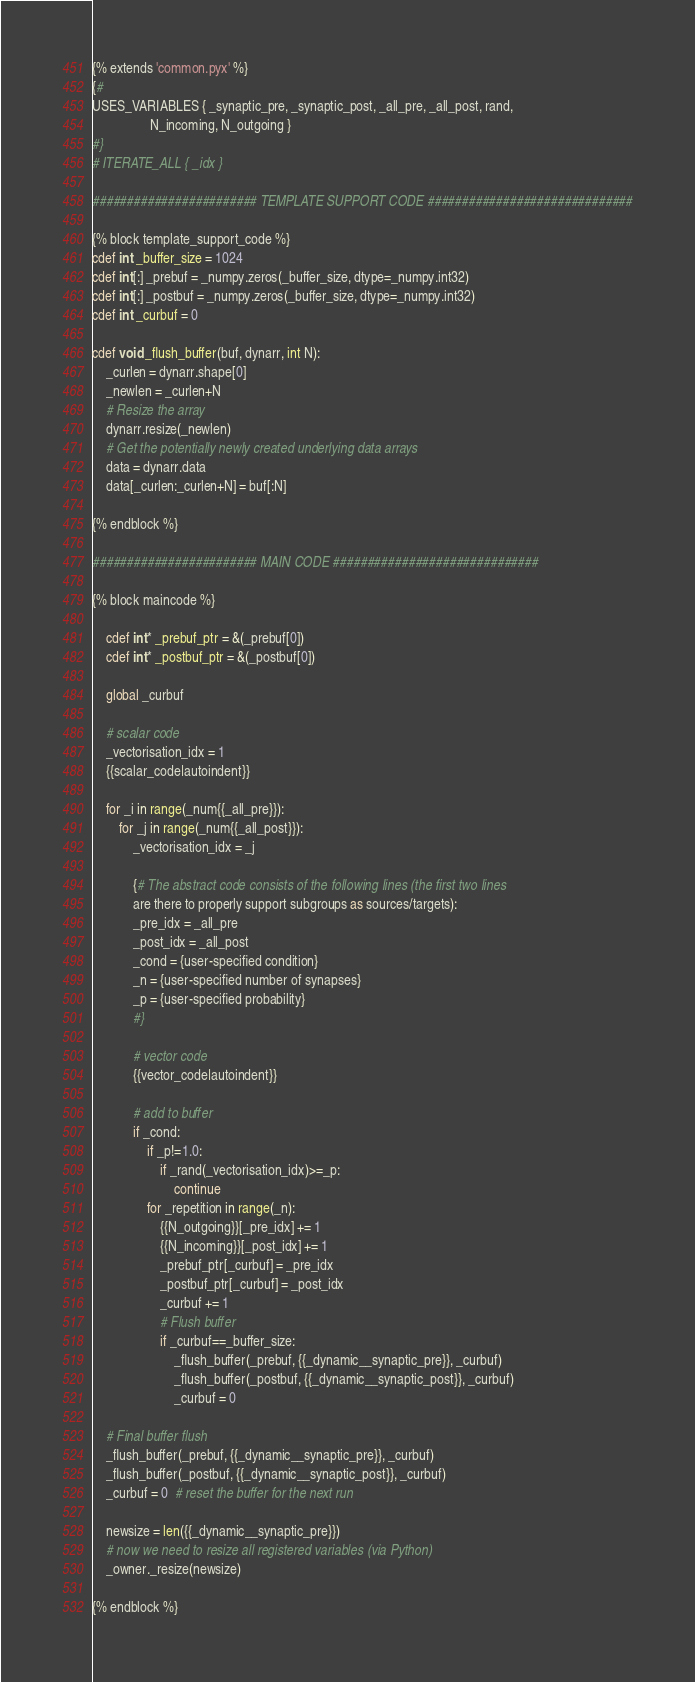Convert code to text. <code><loc_0><loc_0><loc_500><loc_500><_Cython_>{% extends 'common.pyx' %}
{#
USES_VARIABLES { _synaptic_pre, _synaptic_post, _all_pre, _all_post, rand,
                 N_incoming, N_outgoing }
#}
# ITERATE_ALL { _idx }

######################## TEMPLATE SUPPORT CODE ##############################

{% block template_support_code %}
cdef int _buffer_size = 1024
cdef int[:] _prebuf = _numpy.zeros(_buffer_size, dtype=_numpy.int32)
cdef int[:] _postbuf = _numpy.zeros(_buffer_size, dtype=_numpy.int32)
cdef int _curbuf = 0

cdef void _flush_buffer(buf, dynarr, int N):
    _curlen = dynarr.shape[0]
    _newlen = _curlen+N
    # Resize the array
    dynarr.resize(_newlen)
    # Get the potentially newly created underlying data arrays
    data = dynarr.data
    data[_curlen:_curlen+N] = buf[:N]
    
{% endblock %}

######################## MAIN CODE ##############################

{% block maincode %}

    cdef int* _prebuf_ptr = &(_prebuf[0])
    cdef int* _postbuf_ptr = &(_postbuf[0])

    global _curbuf
    
    # scalar code
    _vectorisation_idx = 1
    {{scalar_code|autoindent}}

    for _i in range(_num{{_all_pre}}):
        for _j in range(_num{{_all_post}}):
            _vectorisation_idx = _j

            {# The abstract code consists of the following lines (the first two lines
            are there to properly support subgroups as sources/targets):
            _pre_idx = _all_pre
            _post_idx = _all_post
            _cond = {user-specified condition}
            _n = {user-specified number of synapses}
            _p = {user-specified probability}
            #}
            
            # vector code
            {{vector_code|autoindent}}
            
            # add to buffer
            if _cond:
                if _p!=1.0:
                    if _rand(_vectorisation_idx)>=_p:
                        continue
                for _repetition in range(_n):
                    {{N_outgoing}}[_pre_idx] += 1
                    {{N_incoming}}[_post_idx] += 1
                    _prebuf_ptr[_curbuf] = _pre_idx
                    _postbuf_ptr[_curbuf] = _post_idx
                    _curbuf += 1
                    # Flush buffer
                    if _curbuf==_buffer_size:
                        _flush_buffer(_prebuf, {{_dynamic__synaptic_pre}}, _curbuf)
                        _flush_buffer(_postbuf, {{_dynamic__synaptic_post}}, _curbuf)
                        _curbuf = 0
                        
    # Final buffer flush
    _flush_buffer(_prebuf, {{_dynamic__synaptic_pre}}, _curbuf)
    _flush_buffer(_postbuf, {{_dynamic__synaptic_post}}, _curbuf)
    _curbuf = 0  # reset the buffer for the next run

    newsize = len({{_dynamic__synaptic_pre}})
    # now we need to resize all registered variables (via Python)
    _owner._resize(newsize)

{% endblock %}
</code> 